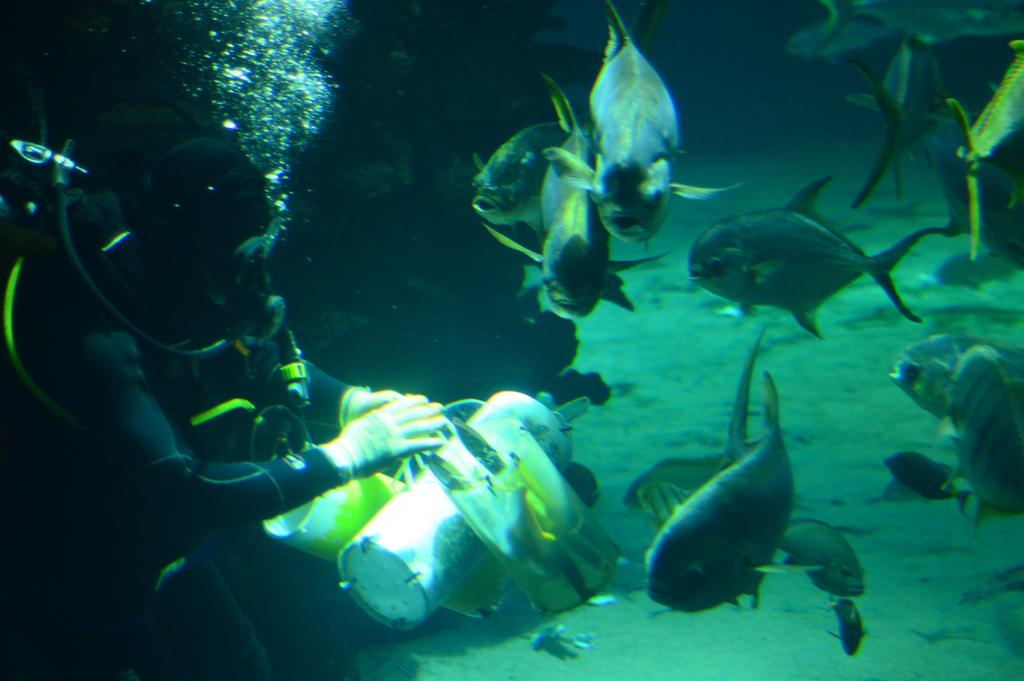Where is the image taken? The image is taken in the sea. What can be seen on the left side of the image? There is a man on the left side of the image. What is present on the right side of the image? There are many fishes on the right side of the image. What type of shirt is the man wearing in the image? There is no information about the man's shirt in the image. What type of thrill can be experienced by the fishes in the image? The image does not convey any emotions or experiences of the fishes, so it is not possible to determine if they are experiencing any thrill. 